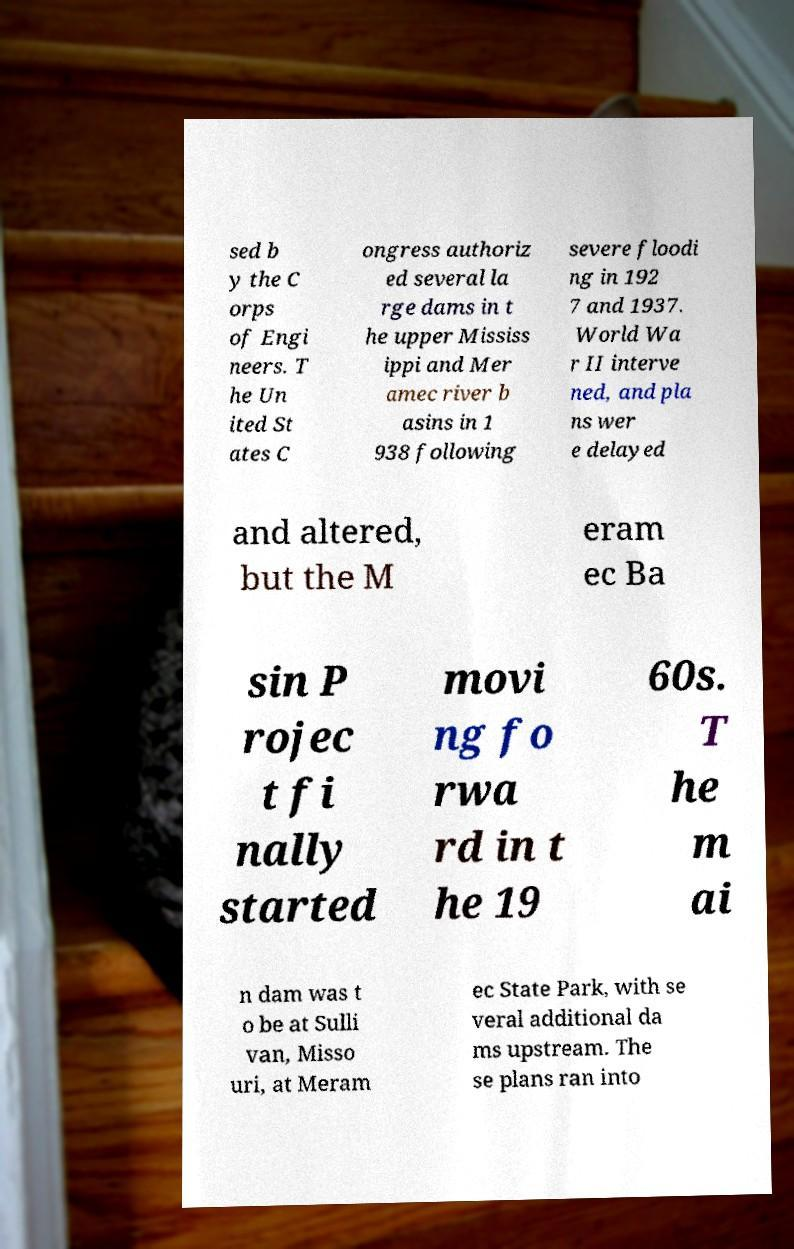Could you extract and type out the text from this image? sed b y the C orps of Engi neers. T he Un ited St ates C ongress authoriz ed several la rge dams in t he upper Mississ ippi and Mer amec river b asins in 1 938 following severe floodi ng in 192 7 and 1937. World Wa r II interve ned, and pla ns wer e delayed and altered, but the M eram ec Ba sin P rojec t fi nally started movi ng fo rwa rd in t he 19 60s. T he m ai n dam was t o be at Sulli van, Misso uri, at Meram ec State Park, with se veral additional da ms upstream. The se plans ran into 